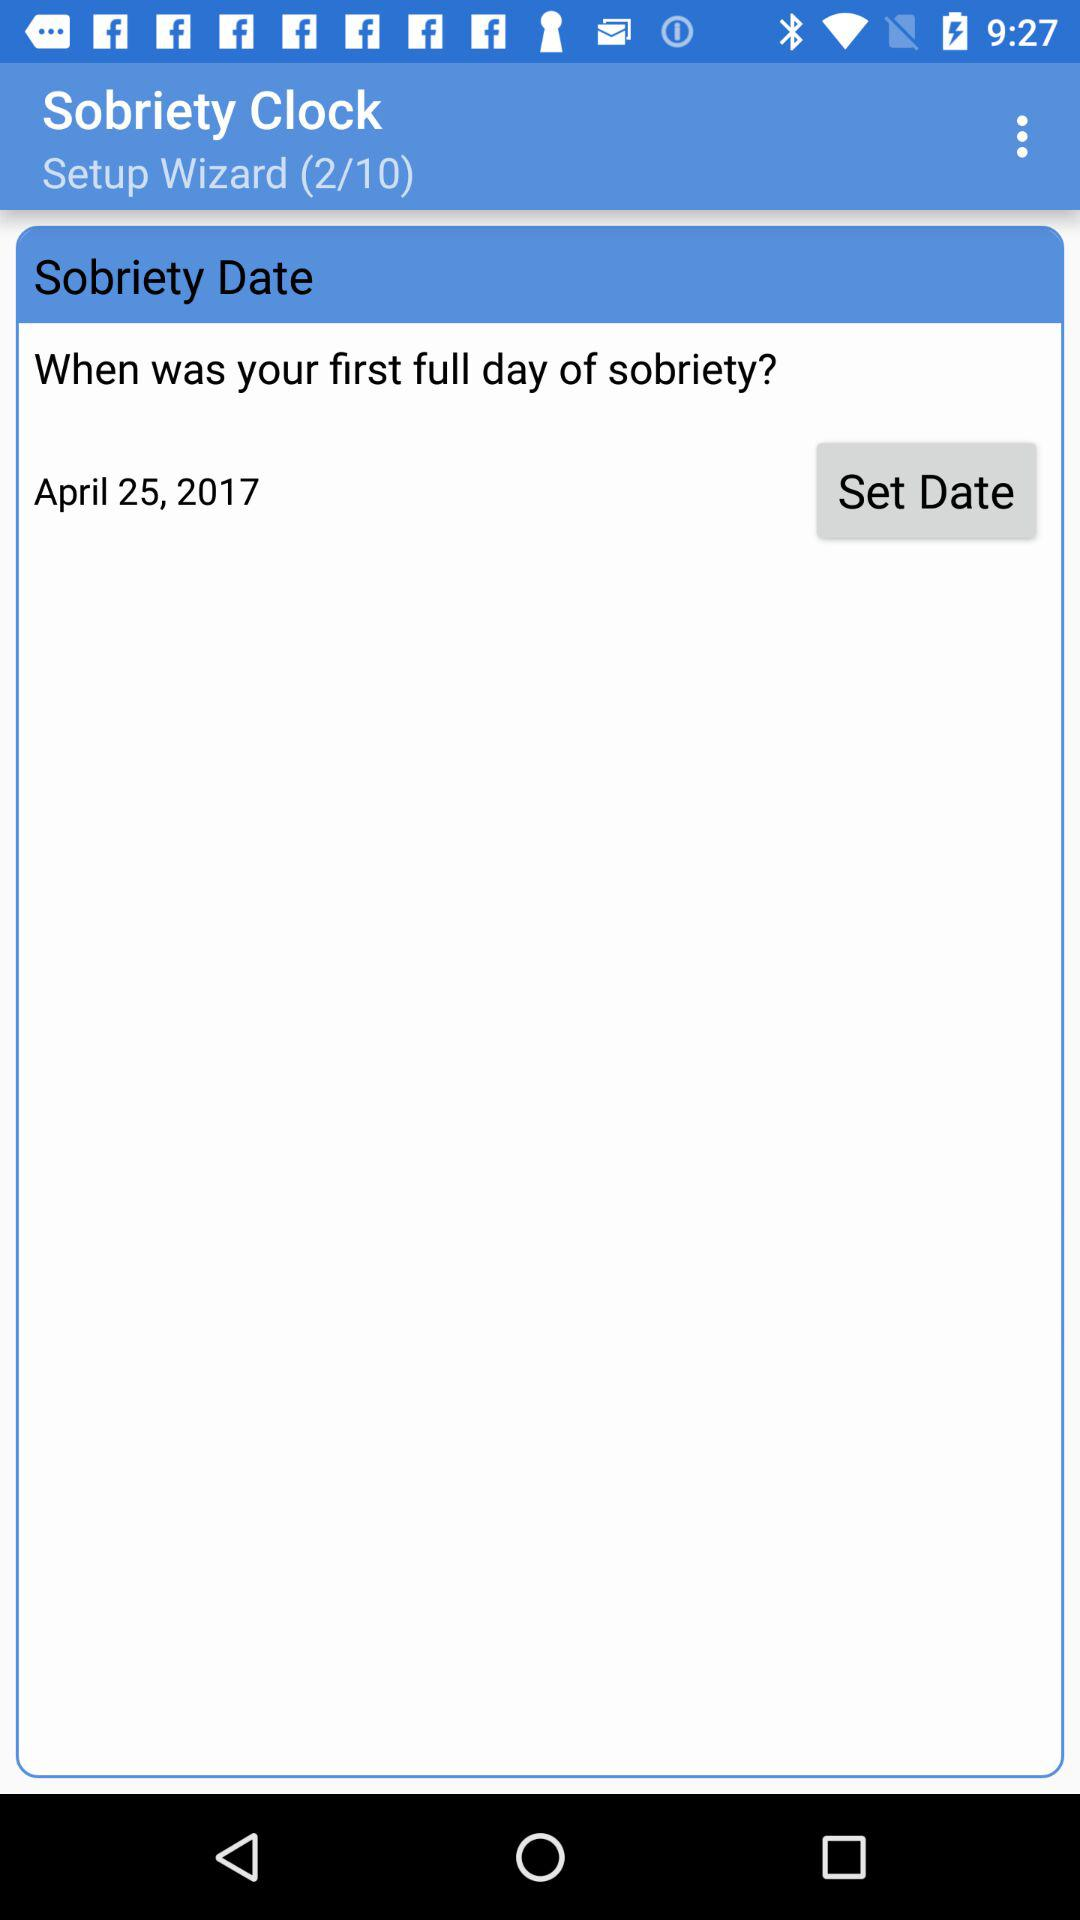At what number of processes are we currently at? We are currently at process number 2. 